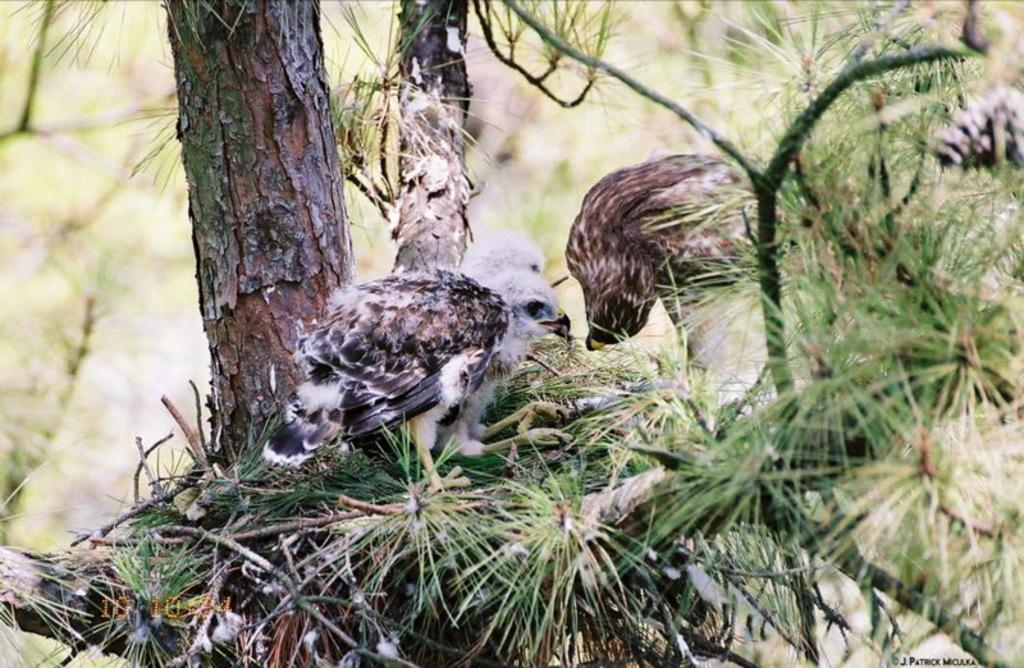What animals can be seen on the tree in the image? There are birds on the tree in the image. What type of vegetation is present on the tree? Leaves are present on the tree, along with branches and stems. What is the appearance of the background in the image? The background has a blurred view. Are there any additional features at the bottom of the image? Yes, there are watermarks at the bottom of the image. Can you see a rat pushing a daughter in the image? No, there is no rat or daughter present in the image. 